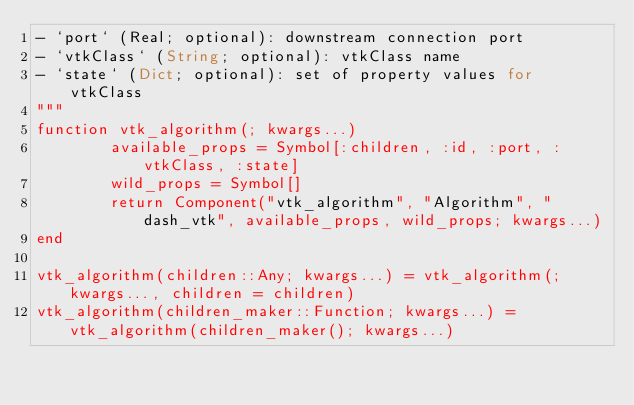Convert code to text. <code><loc_0><loc_0><loc_500><loc_500><_Julia_>- `port` (Real; optional): downstream connection port
- `vtkClass` (String; optional): vtkClass name
- `state` (Dict; optional): set of property values for vtkClass
"""
function vtk_algorithm(; kwargs...)
        available_props = Symbol[:children, :id, :port, :vtkClass, :state]
        wild_props = Symbol[]
        return Component("vtk_algorithm", "Algorithm", "dash_vtk", available_props, wild_props; kwargs...)
end

vtk_algorithm(children::Any; kwargs...) = vtk_algorithm(;kwargs..., children = children)
vtk_algorithm(children_maker::Function; kwargs...) = vtk_algorithm(children_maker(); kwargs...)

</code> 